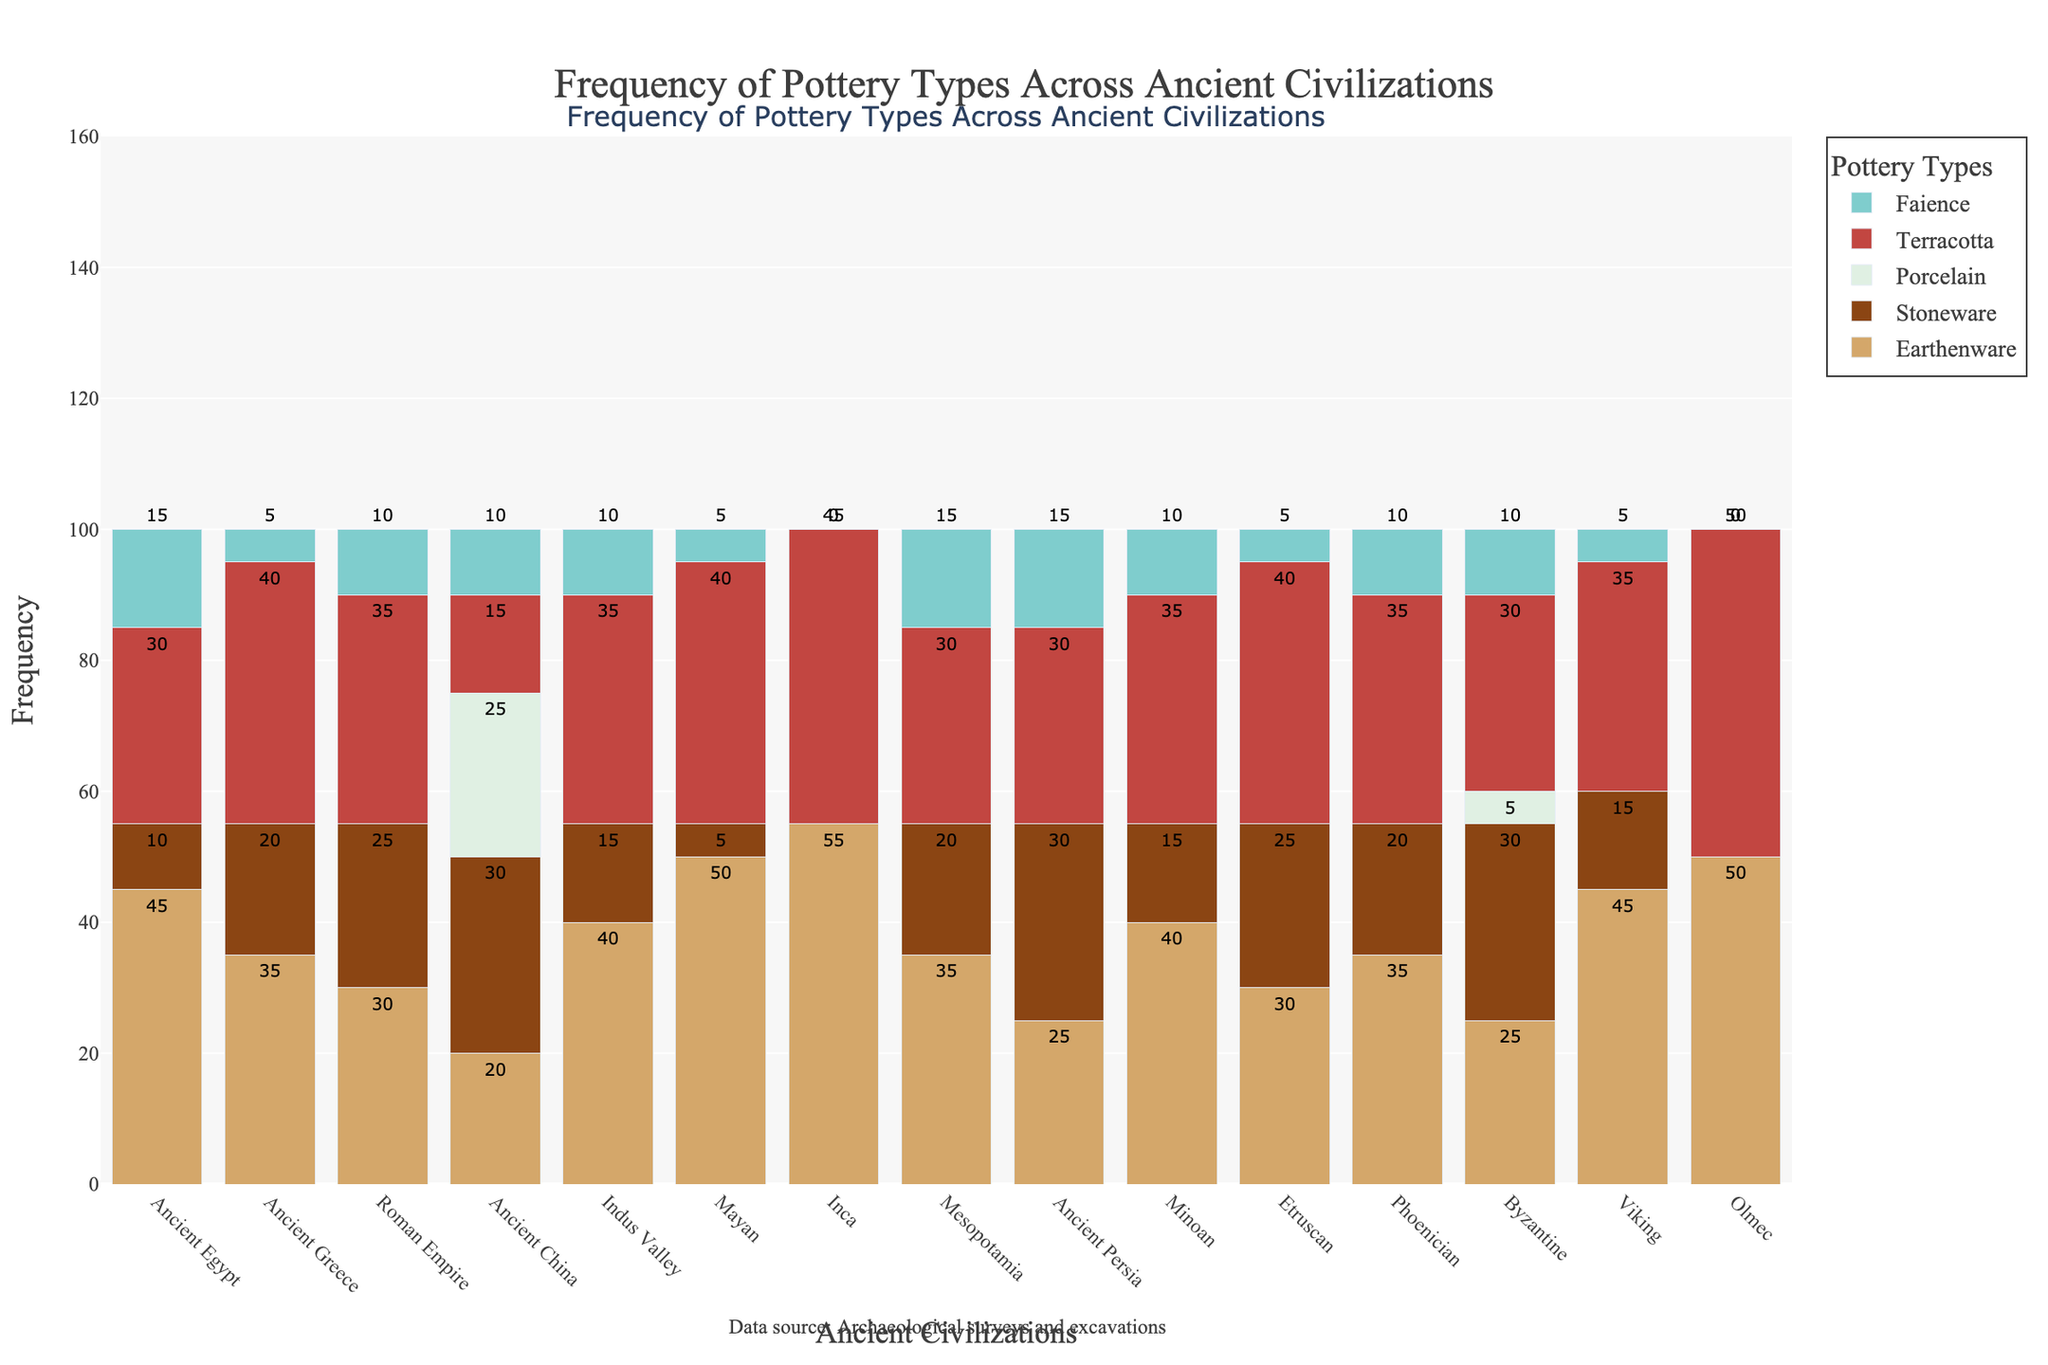What ancient civilization found the most Porcelain pottery? By examining the height of the Porcelain bars for each civilization, Ancient China stands out as the only civilization with a notable amount of Porcelain.
Answer: Ancient China Which civilization found the highest frequency of Earthenware? To determine this, compare the heights of the Earthenware bars. The Inca civilization has the tallest Earthenware bar.
Answer: Inca Between Ancient Egypt and the Roman Empire, which civilization has a higher combined frequency of Terracotta and Faience pottery? Sum the frequencies of Terracotta and Faience for both civilizations. Ancient Egypt has (30 + 15) = 45, and Roman Empire has (35 + 10) = 45. Both are equal.
Answer: Equal What is the total frequency of Stoneware found in Ancient China and Ancient Persia? Add the Stoneware frequencies of Ancient China and Ancient Persia. Ancient China has 30, and Ancient Persia has 30, so the total is (30 + 30) = 60.
Answer: 60 Which type of pottery is exclusively found in only one civilization? By scanning the bars, Porcelain is exclusively found in Ancient China.
Answer: Porcelain Which civilization has a higher frequency of Faience, Mesopotamia or Viking? Compare the heights of the Faience bars for both civilizations. Both Mesopotamia and Viking have the same height for Faience, which is 15.
Answer: Equal How does the frequency of Earthenware in the Mayan civilization compare to that in the Olmec civilization? Compare the heights of the Earthenware bars for the Mayan and Olmec civilizations. Mayan has 50, and Olmec also has 50, so they are equal.
Answer: Equal What is the average frequency of Stoneware pottery found across Ancient Egypt, Ancient Greece, and the Roman Empire? Add the Stoneware frequencies for these three civilizations and then divide by 3. Ancient Egypt has 10, Ancient Greece has 20, and Roman Empire has 25, summing up to (10 + 20 + 25) = 55. The average is 55/3 ≈ 18.33.
Answer: 18.33 